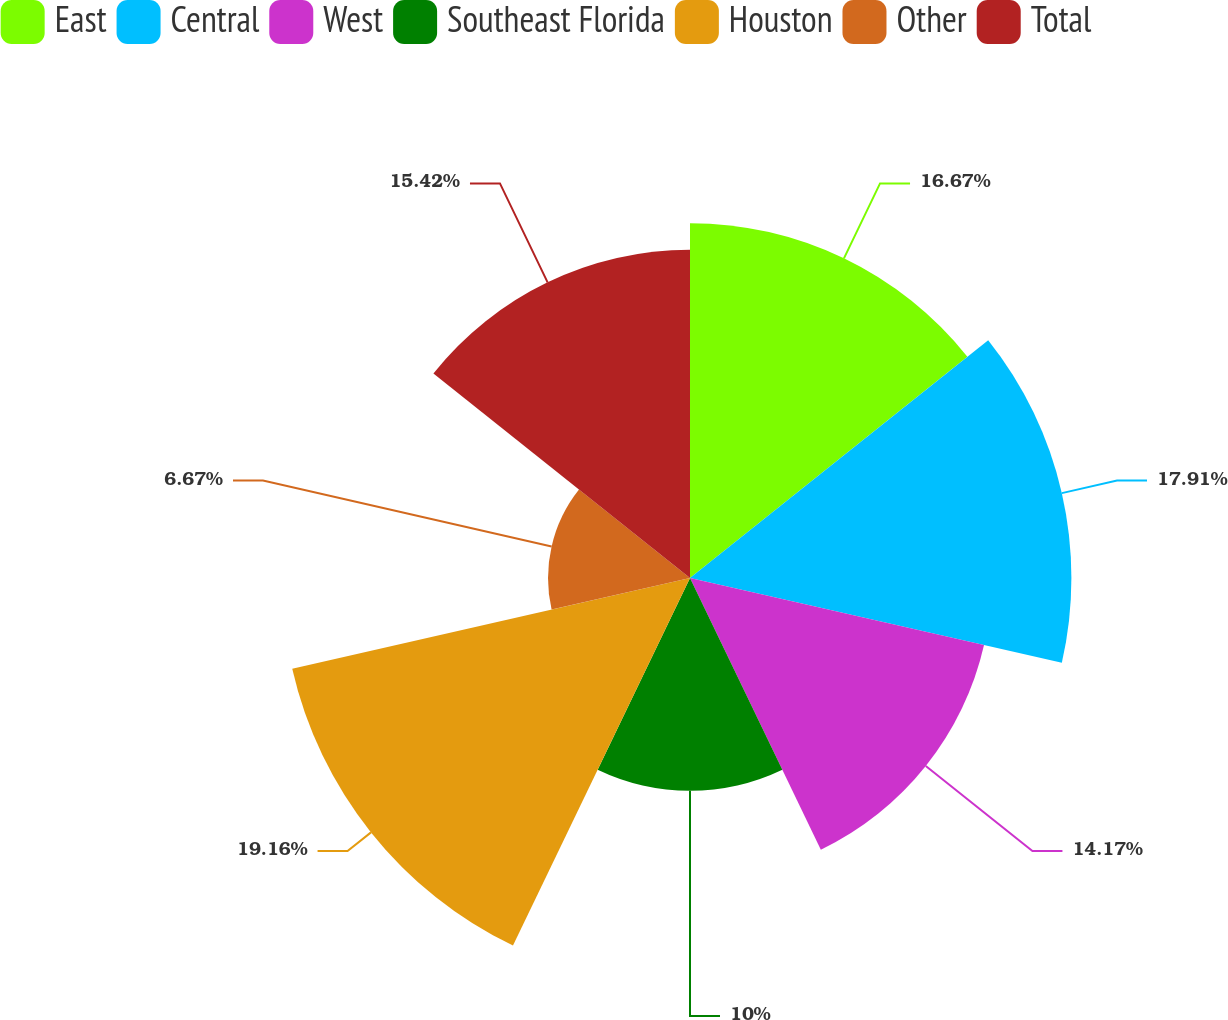<chart> <loc_0><loc_0><loc_500><loc_500><pie_chart><fcel>East<fcel>Central<fcel>West<fcel>Southeast Florida<fcel>Houston<fcel>Other<fcel>Total<nl><fcel>16.67%<fcel>17.92%<fcel>14.17%<fcel>10.0%<fcel>19.17%<fcel>6.67%<fcel>15.42%<nl></chart> 